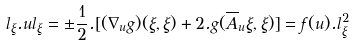<formula> <loc_0><loc_0><loc_500><loc_500>l _ { \xi } . u l _ { \xi } = \pm \frac { 1 } { 2 } . [ ( \nabla _ { u } g ) ( \xi , \xi ) + 2 . g ( \overline { A } _ { u } \xi , \xi ) ] = f ( u ) . l _ { \xi } ^ { 2 } \text { }</formula> 